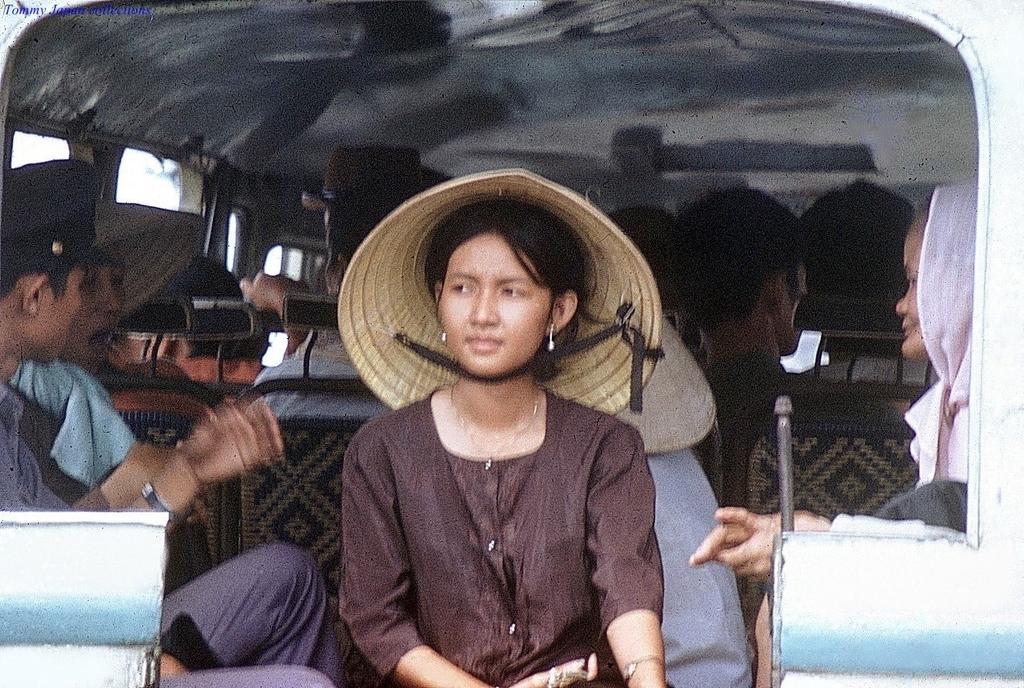How would you summarize this image in a sentence or two? In the picture I can see a few persons sitting in the vehicle. In the foreground I can see a woman and there is a wooden cap on her head. I can see two persons on the left side and there is a cap on their head. 